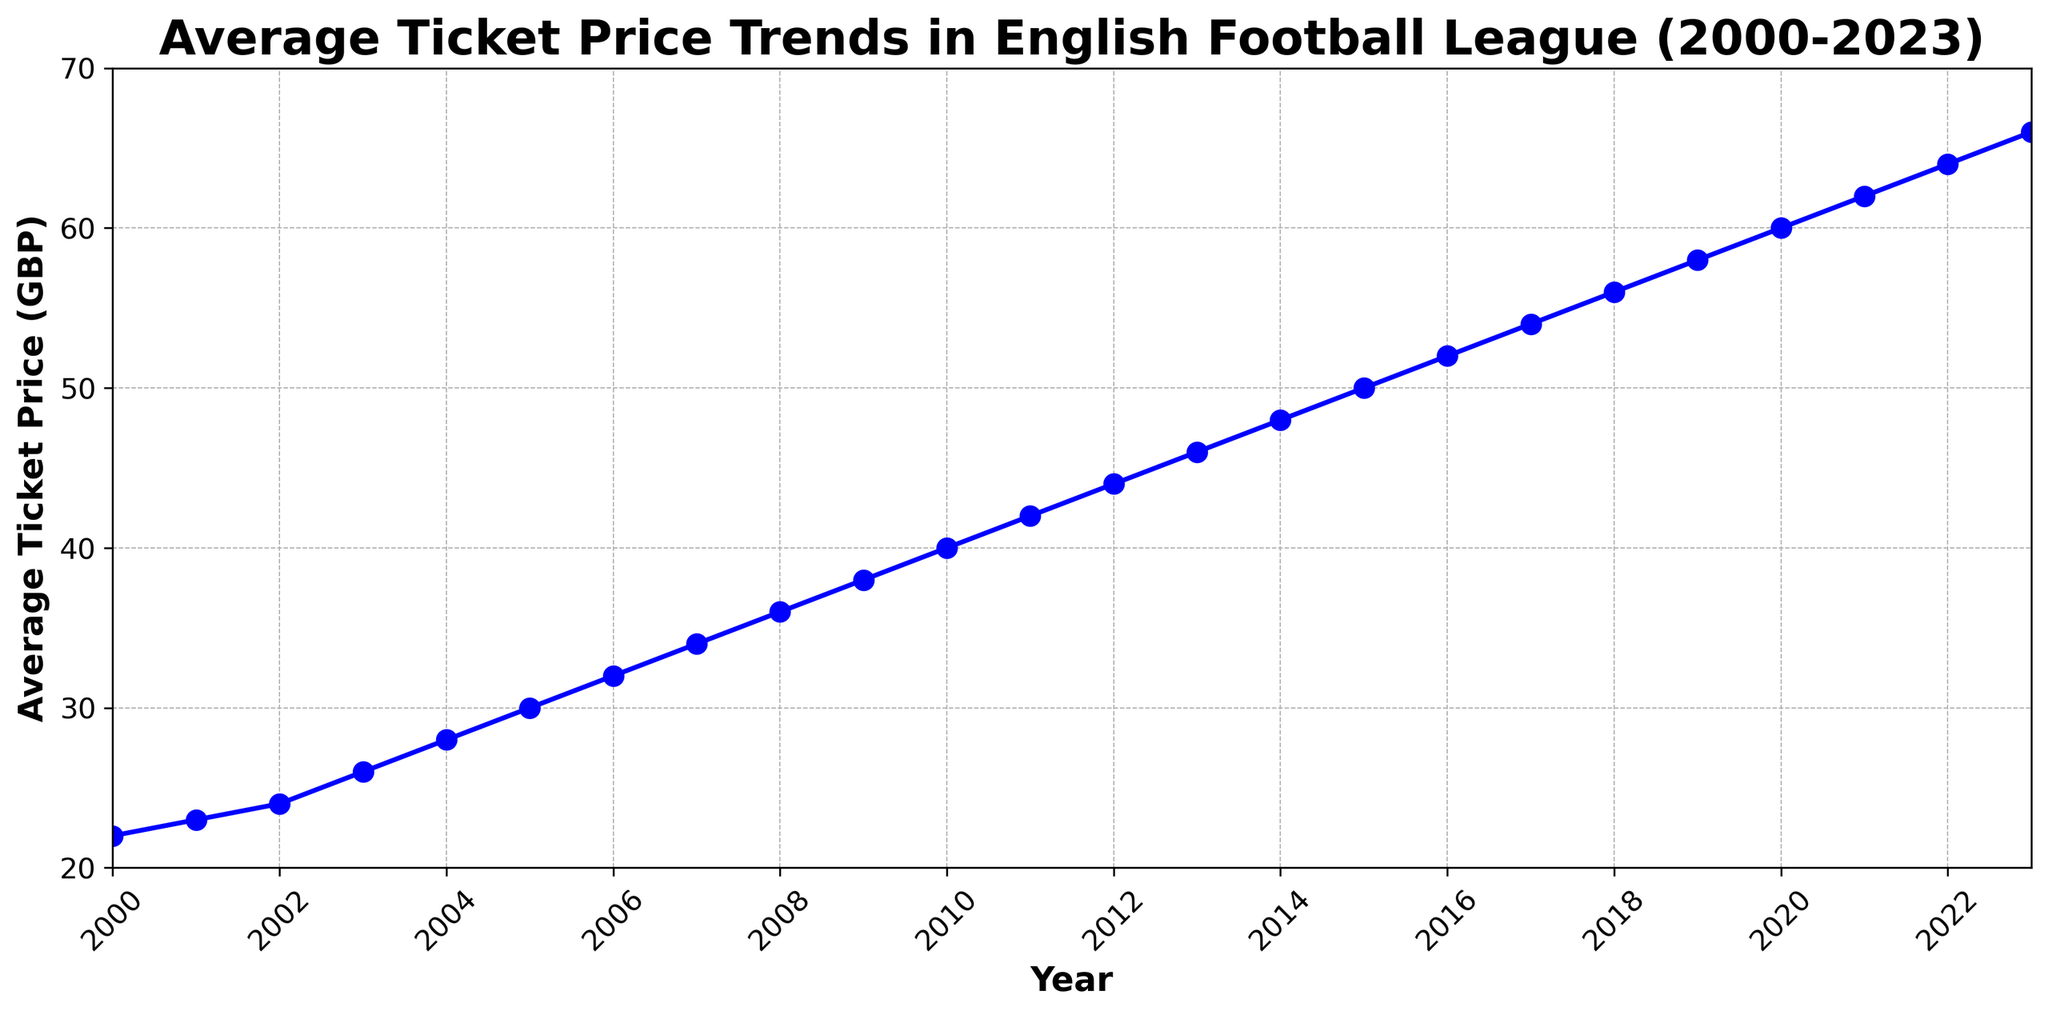What's the average ticket price trend shown in the figure? The plot shows a line graph where the average ticket price in GBP increases over the years from 2000 to 2023. The trend is upward without any major dips or periods of stagnation.
Answer: Upward trend In which year did the average ticket price reach £50? By looking at the curve on the plot, the average ticket price reaches £50 in the year 2015.
Answer: 2015 What is the difference in the average ticket price between 2000 and 2023? The average ticket price in 2000 is £22, and in 2023 it is £66. The difference can be calculated as £66 - £22 = £44.
Answer: £44 Which years show the steepest increase in ticket prices? Visually, the steepest increases in ticket prices appear to occur between 2004 to 2009, as evidenced by the sharper slope of the line in this time interval.
Answer: 2004 to 2009 What was the ticket price growth rate per year on average from 2000 to 2023? The ticket price increased from £22 in 2000 to £66 in 2023. The growth rate per year can be calculated as (66 - 22) / (2023 - 2000) = £44 / 23 ≈ £1.91 per year.
Answer: £1.91 per year Compare the average ticket prices in 2010 and 2020. In 2010, the average ticket price is £40 and in 2020 it is £60. Hence, £60 - £40 = £20, the ticket price in 2020 is £20 higher than in 2010.
Answer: £20 higher What is the percentage increase in ticket prices from 2000 to 2023? The ticket price increased from £22 in 2000 to £66 in 2023. The percentage increase can be calculated as ((66 - 22) / 22) * 100 = (44 / 22) * 100 ≈ 200%.
Answer: 200% In which year did the average ticket price cross the £30 mark? Observing the graph, the average ticket price crosses the £30 mark in the year 2005.
Answer: 2005 What is the average ticket price over the first decade (2000-2010)? To find the average price from 2000 to 2010, add the ticket prices and divide by the number of years: (22 + 23 + 24 + 26 + 28 + 30 + 32 + 34 + 36 + 38 + 40) / 11 ≈ 30.
Answer: 30 